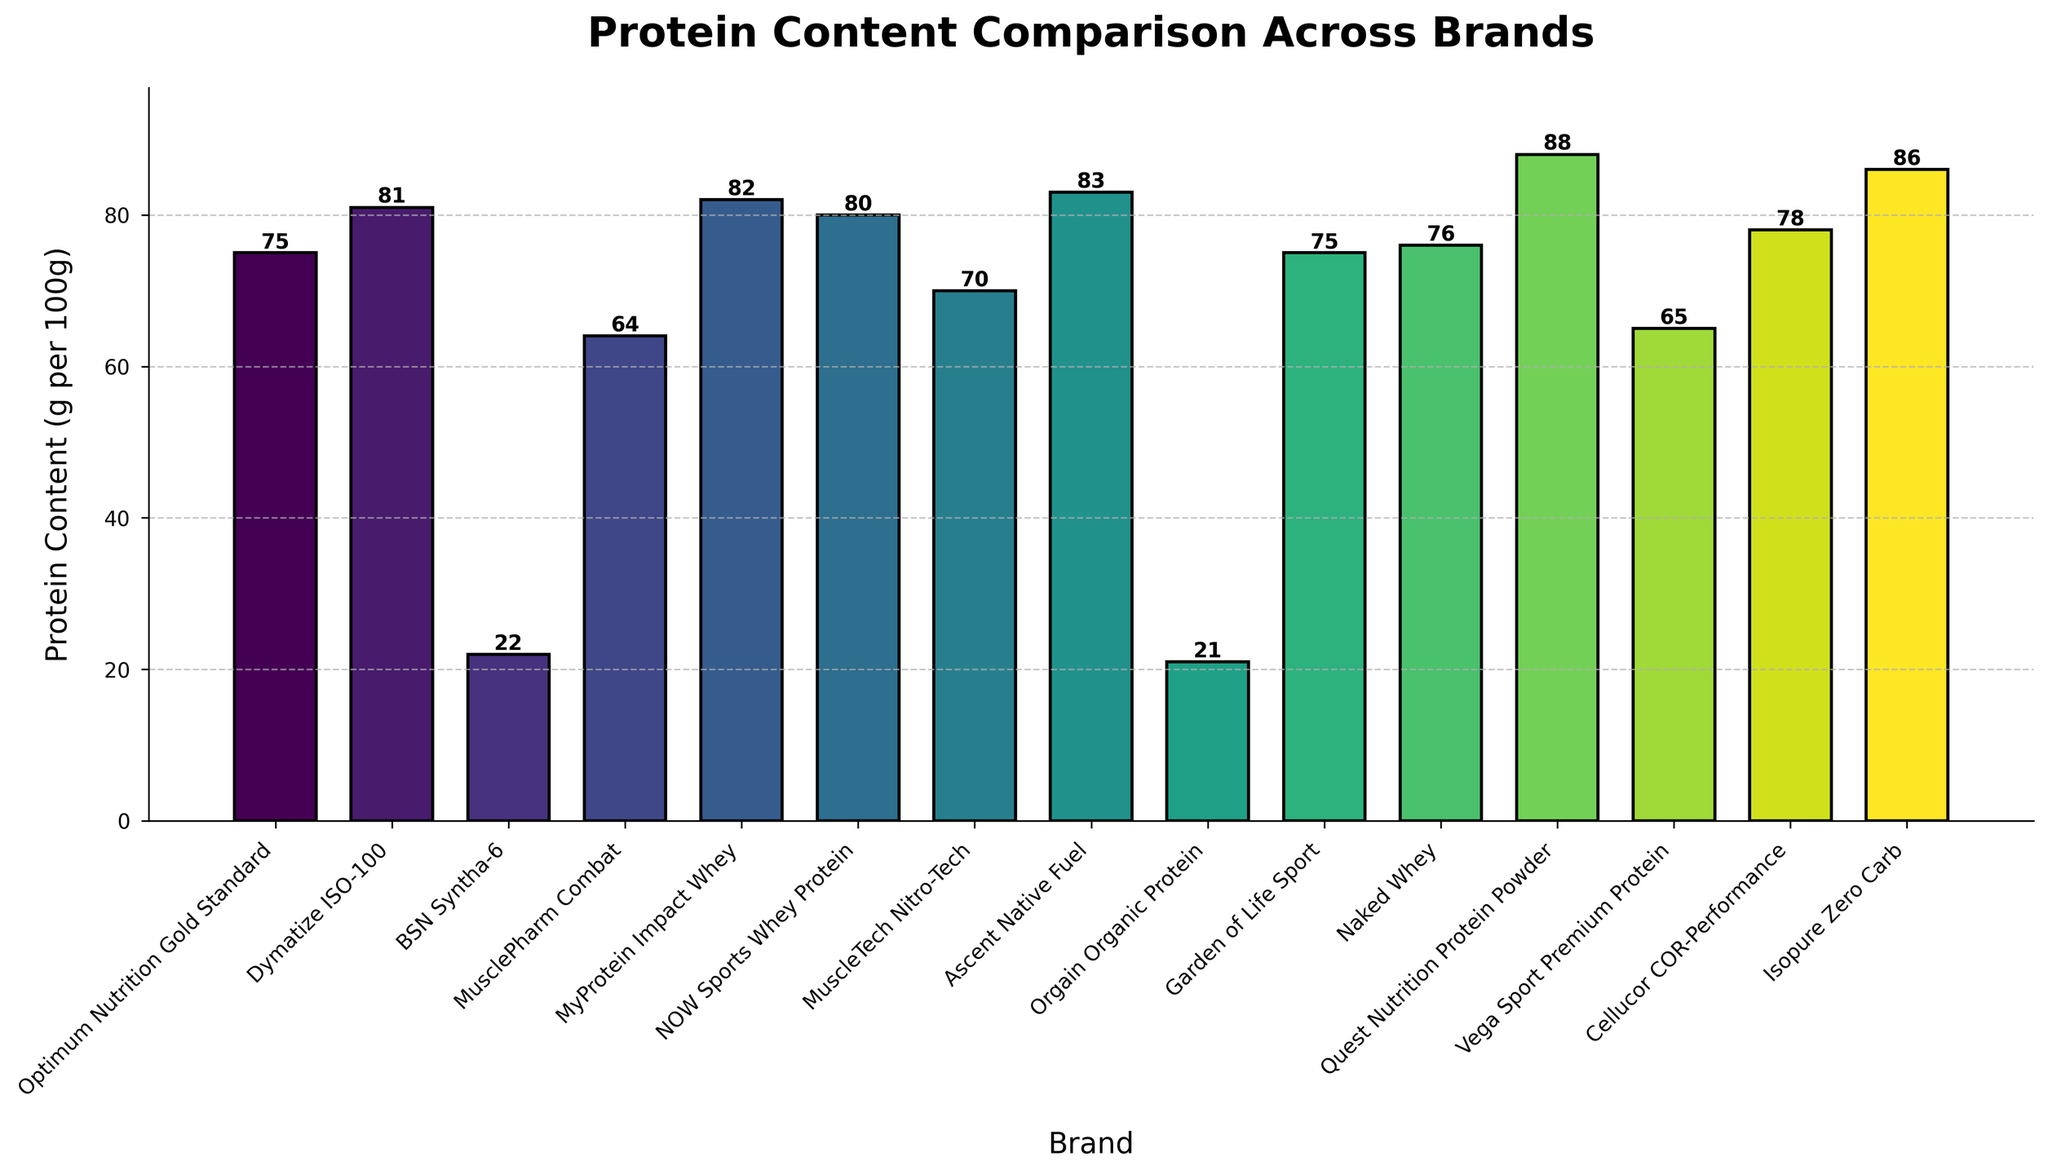Which brand has the highest protein content? By scanning the heights of the bars, the tallest bar represents Quest Nutrition Protein Powder with 88 grams of protein per 100 grams.
Answer: Quest Nutrition Protein Powder Which brand has the lowest protein content? By observing the bar heights, the shortest bar belongs to Orgain Organic Protein with 21 grams of protein per 100 grams.
Answer: Orgain Organic Protein How much more protein content does MyProtein Impact Whey have compared to MuscleTech Nitro-Tech? MyProtein Impact Whey has 82 grams of protein per 100 grams while MuscleTech Nitro-Tech has 70 grams. The difference is 82 - 70 = 12 grams.
Answer: 12 grams Which brands have exactly the same protein content? By checking the bar heights, Garden of Life Sport and Optimum Nutrition Gold Standard both have bars that indicate 75 grams of protein per 100 grams.
Answer: Garden of Life Sport and Optimum Nutrition Gold Standard What is the median protein content of all brands? The data points in ascending order are 21, 22, 64, 65, 70, 75, 75, 76, 78, 80, 81, 82, 83, 86, 88. With 15 data points, the median is the 8th value: 76 grams.
Answer: 76 grams How many brands offer protein content greater than 80 grams per 100 grams? Brands with protein contents greater than 80 grams are Dymatize ISO-100 (81), MyProtein Impact Whey (82), Ascent Native Fuel (83), Isopure Zero Carb (86), and Quest Nutrition Protein Powder (88). There are 5 such brands.
Answer: 5 Which brands have protein content within 5 grams of MusclePharm Combat? MusclePharm Combat has 64 grams of protein. Brands with protein content within 59 to 69 grams are Vega Sport Premium Protein (65) and MuscleTech Nitro-Tech (70).
Answer: Vega Sport Premium Protein and MuscleTech Nitro-Tech Are there more brands with protein content above or below the median value? The median protein content is 76 grams. Brands with protein content above 76 grams are 7, and those below are 7, plus one at the median value of 76.
Answer: Equal What is the total protein content for the top 3 brands? The top three brands by protein content are Quest Nutrition Protein Powder (88), Isopure Zero Carb (86), and Ascent Native Fuel (83). The total is 88 + 86 + 83 = 257 grams.
Answer: 257 grams 